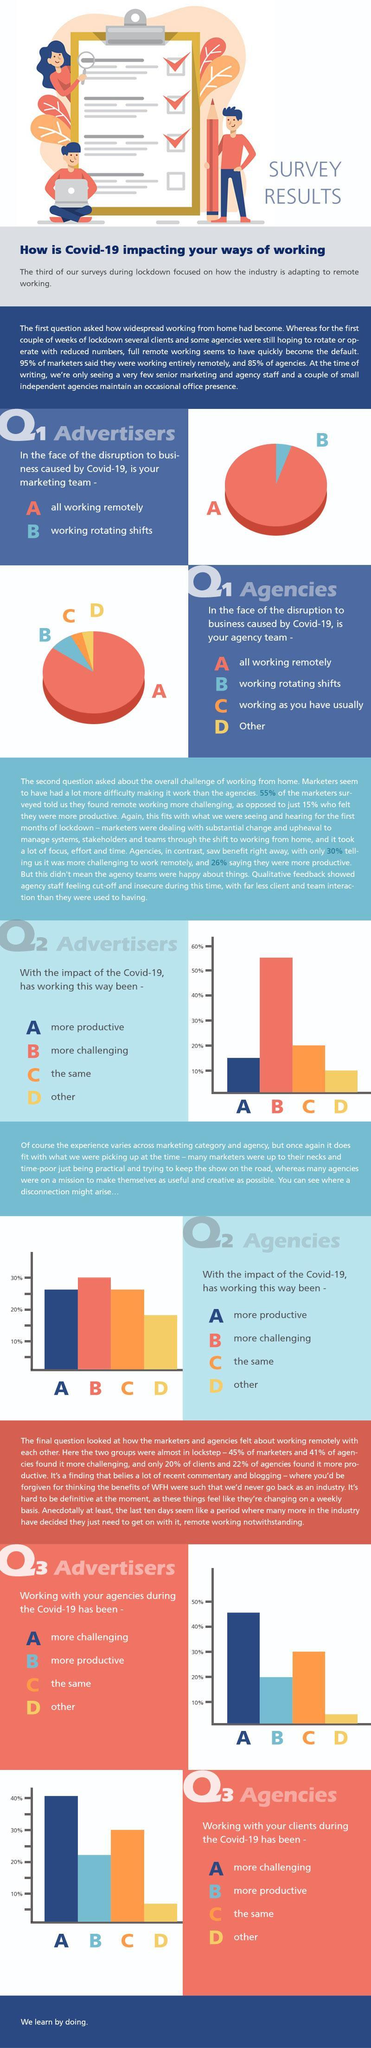Which is the second most option selected by people participated in the survey of Q3 advertisers?
Answer the question with a short phrase. the same What percentage of people voted for the survey of Q2 Advertisers "work has been more productive with the impact of Covid- 19"? 15% Which is the third most option selected by people participated in the survey of Q3 agencies? more productive What percentage of people voted for "Other" option in the survey of Q3 Advertisers ? 5% Which is the second most option selected by people participated in the survey of Q3 agencies? the same What percentage of people voted for the survey of Q3 Advertisers "working with agencies has been more challenging during Covid- 19"? 45% Which is the option most favoured by people who participated in the survey of Q3 Advertisers A, B, C, D? A What percentage of people voted for the survey of Q2 Advertisers "work has been more challenging with the impact of Covid- 19"? 55% 